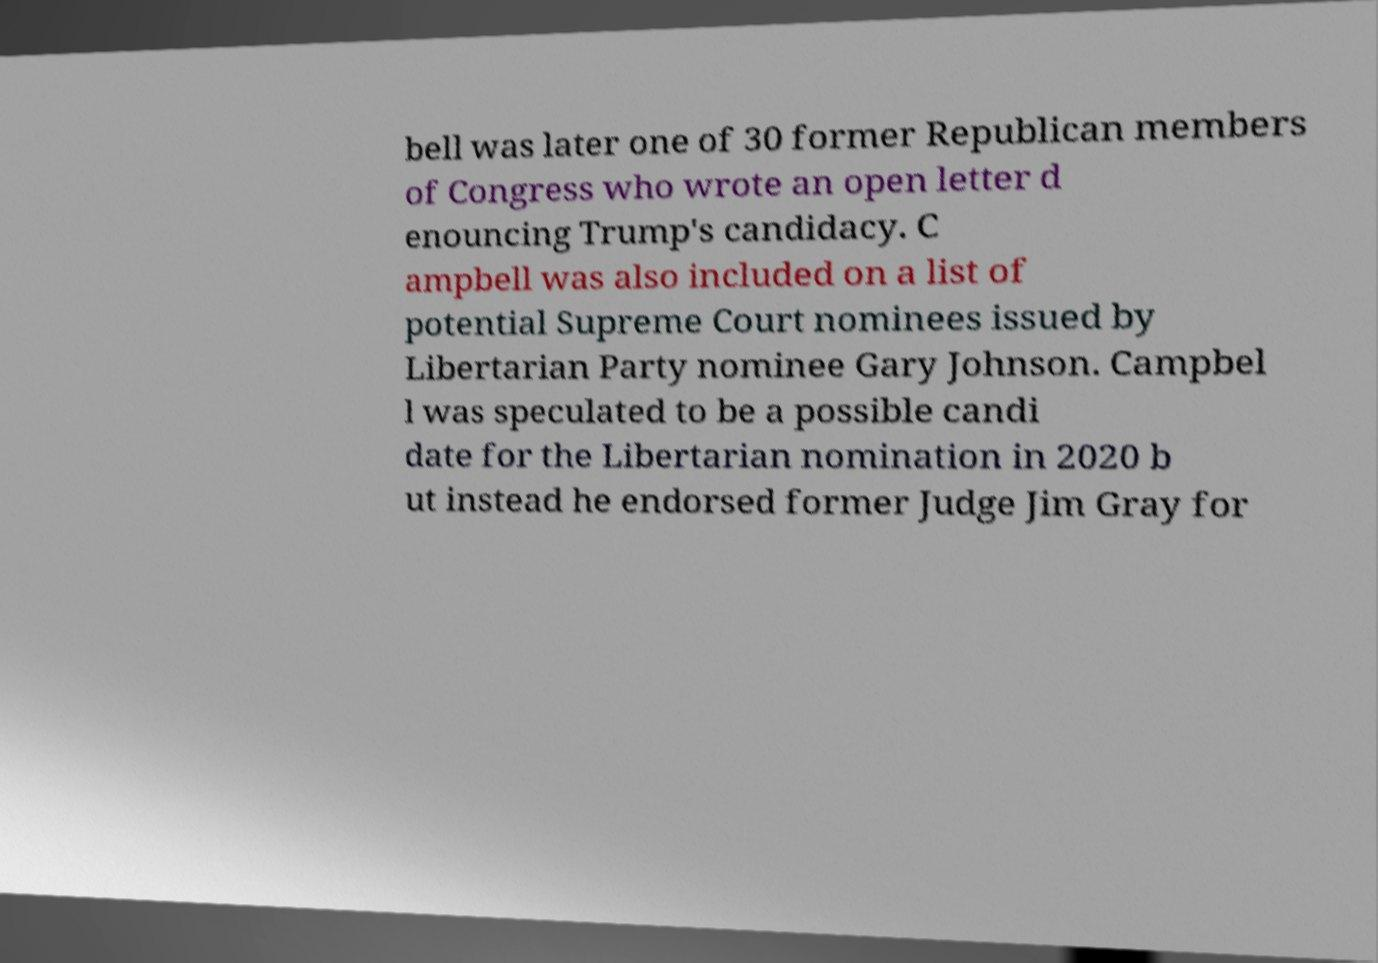For documentation purposes, I need the text within this image transcribed. Could you provide that? bell was later one of 30 former Republican members of Congress who wrote an open letter d enouncing Trump's candidacy. C ampbell was also included on a list of potential Supreme Court nominees issued by Libertarian Party nominee Gary Johnson. Campbel l was speculated to be a possible candi date for the Libertarian nomination in 2020 b ut instead he endorsed former Judge Jim Gray for 